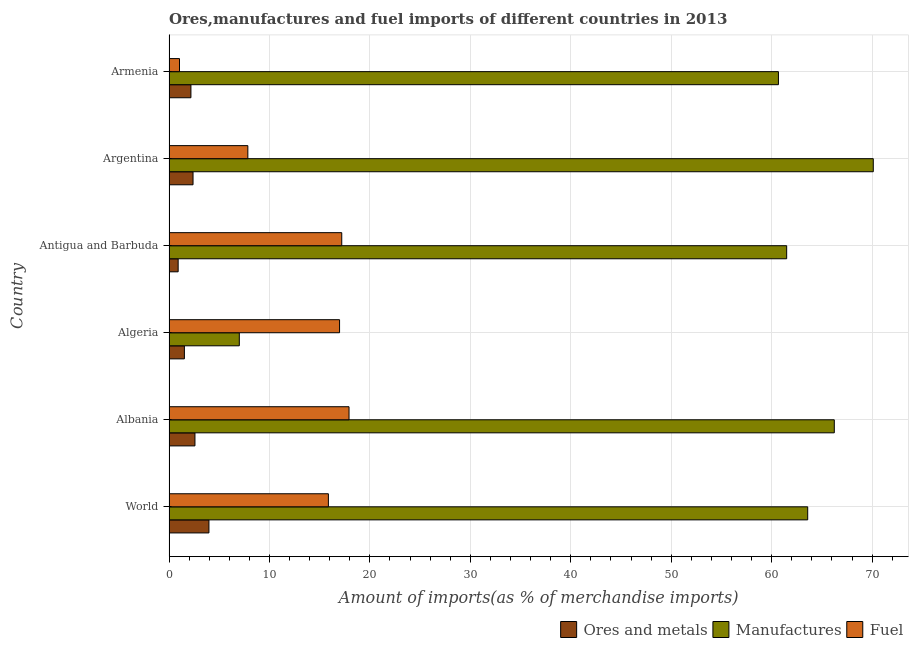How many groups of bars are there?
Offer a terse response. 6. Are the number of bars per tick equal to the number of legend labels?
Provide a succinct answer. Yes. What is the label of the 6th group of bars from the top?
Provide a short and direct response. World. What is the percentage of manufactures imports in World?
Provide a short and direct response. 63.59. Across all countries, what is the maximum percentage of manufactures imports?
Offer a terse response. 70.11. Across all countries, what is the minimum percentage of manufactures imports?
Make the answer very short. 7. In which country was the percentage of ores and metals imports maximum?
Provide a short and direct response. World. In which country was the percentage of fuel imports minimum?
Offer a terse response. Armenia. What is the total percentage of fuel imports in the graph?
Ensure brevity in your answer.  76.86. What is the difference between the percentage of manufactures imports in Albania and that in Antigua and Barbuda?
Your response must be concise. 4.74. What is the difference between the percentage of fuel imports in Argentina and the percentage of manufactures imports in Algeria?
Provide a short and direct response. 0.85. What is the average percentage of ores and metals imports per country?
Provide a succinct answer. 2.26. What is the difference between the percentage of fuel imports and percentage of ores and metals imports in Armenia?
Provide a short and direct response. -1.14. What is the ratio of the percentage of manufactures imports in Albania to that in Algeria?
Your response must be concise. 9.46. Is the difference between the percentage of manufactures imports in Armenia and World greater than the difference between the percentage of ores and metals imports in Armenia and World?
Provide a short and direct response. No. What is the difference between the highest and the second highest percentage of manufactures imports?
Your answer should be very brief. 3.88. What is the difference between the highest and the lowest percentage of manufactures imports?
Provide a succinct answer. 63.11. What does the 3rd bar from the top in Argentina represents?
Your response must be concise. Ores and metals. What does the 2nd bar from the bottom in World represents?
Provide a short and direct response. Manufactures. Is it the case that in every country, the sum of the percentage of ores and metals imports and percentage of manufactures imports is greater than the percentage of fuel imports?
Ensure brevity in your answer.  No. Are the values on the major ticks of X-axis written in scientific E-notation?
Offer a very short reply. No. Does the graph contain any zero values?
Provide a succinct answer. No. Where does the legend appear in the graph?
Your answer should be compact. Bottom right. How are the legend labels stacked?
Give a very brief answer. Horizontal. What is the title of the graph?
Make the answer very short. Ores,manufactures and fuel imports of different countries in 2013. Does "Industrial Nitrous Oxide" appear as one of the legend labels in the graph?
Make the answer very short. No. What is the label or title of the X-axis?
Provide a short and direct response. Amount of imports(as % of merchandise imports). What is the Amount of imports(as % of merchandise imports) in Ores and metals in World?
Your answer should be compact. 3.98. What is the Amount of imports(as % of merchandise imports) in Manufactures in World?
Your answer should be very brief. 63.59. What is the Amount of imports(as % of merchandise imports) in Fuel in World?
Your answer should be compact. 15.87. What is the Amount of imports(as % of merchandise imports) of Ores and metals in Albania?
Provide a succinct answer. 2.58. What is the Amount of imports(as % of merchandise imports) in Manufactures in Albania?
Provide a succinct answer. 66.23. What is the Amount of imports(as % of merchandise imports) of Fuel in Albania?
Your response must be concise. 17.92. What is the Amount of imports(as % of merchandise imports) of Ores and metals in Algeria?
Your answer should be very brief. 1.53. What is the Amount of imports(as % of merchandise imports) of Manufactures in Algeria?
Offer a terse response. 7. What is the Amount of imports(as % of merchandise imports) in Fuel in Algeria?
Offer a very short reply. 16.98. What is the Amount of imports(as % of merchandise imports) of Ores and metals in Antigua and Barbuda?
Provide a succinct answer. 0.91. What is the Amount of imports(as % of merchandise imports) of Manufactures in Antigua and Barbuda?
Make the answer very short. 61.49. What is the Amount of imports(as % of merchandise imports) of Fuel in Antigua and Barbuda?
Your answer should be compact. 17.2. What is the Amount of imports(as % of merchandise imports) of Ores and metals in Argentina?
Provide a short and direct response. 2.39. What is the Amount of imports(as % of merchandise imports) of Manufactures in Argentina?
Offer a very short reply. 70.11. What is the Amount of imports(as % of merchandise imports) of Fuel in Argentina?
Provide a short and direct response. 7.85. What is the Amount of imports(as % of merchandise imports) of Ores and metals in Armenia?
Offer a very short reply. 2.18. What is the Amount of imports(as % of merchandise imports) in Manufactures in Armenia?
Your answer should be very brief. 60.67. What is the Amount of imports(as % of merchandise imports) of Fuel in Armenia?
Your answer should be very brief. 1.05. Across all countries, what is the maximum Amount of imports(as % of merchandise imports) in Ores and metals?
Give a very brief answer. 3.98. Across all countries, what is the maximum Amount of imports(as % of merchandise imports) of Manufactures?
Ensure brevity in your answer.  70.11. Across all countries, what is the maximum Amount of imports(as % of merchandise imports) in Fuel?
Ensure brevity in your answer.  17.92. Across all countries, what is the minimum Amount of imports(as % of merchandise imports) of Ores and metals?
Provide a succinct answer. 0.91. Across all countries, what is the minimum Amount of imports(as % of merchandise imports) in Manufactures?
Give a very brief answer. 7. Across all countries, what is the minimum Amount of imports(as % of merchandise imports) of Fuel?
Make the answer very short. 1.05. What is the total Amount of imports(as % of merchandise imports) in Ores and metals in the graph?
Provide a short and direct response. 13.58. What is the total Amount of imports(as % of merchandise imports) of Manufactures in the graph?
Give a very brief answer. 329.09. What is the total Amount of imports(as % of merchandise imports) of Fuel in the graph?
Provide a succinct answer. 76.86. What is the difference between the Amount of imports(as % of merchandise imports) in Ores and metals in World and that in Albania?
Provide a succinct answer. 1.39. What is the difference between the Amount of imports(as % of merchandise imports) in Manufactures in World and that in Albania?
Your answer should be very brief. -2.65. What is the difference between the Amount of imports(as % of merchandise imports) of Fuel in World and that in Albania?
Offer a terse response. -2.05. What is the difference between the Amount of imports(as % of merchandise imports) of Ores and metals in World and that in Algeria?
Give a very brief answer. 2.44. What is the difference between the Amount of imports(as % of merchandise imports) of Manufactures in World and that in Algeria?
Give a very brief answer. 56.59. What is the difference between the Amount of imports(as % of merchandise imports) in Fuel in World and that in Algeria?
Your response must be concise. -1.11. What is the difference between the Amount of imports(as % of merchandise imports) of Ores and metals in World and that in Antigua and Barbuda?
Make the answer very short. 3.06. What is the difference between the Amount of imports(as % of merchandise imports) of Manufactures in World and that in Antigua and Barbuda?
Provide a succinct answer. 2.09. What is the difference between the Amount of imports(as % of merchandise imports) in Fuel in World and that in Antigua and Barbuda?
Offer a terse response. -1.33. What is the difference between the Amount of imports(as % of merchandise imports) in Ores and metals in World and that in Argentina?
Offer a very short reply. 1.58. What is the difference between the Amount of imports(as % of merchandise imports) of Manufactures in World and that in Argentina?
Your answer should be compact. -6.53. What is the difference between the Amount of imports(as % of merchandise imports) of Fuel in World and that in Argentina?
Make the answer very short. 8.02. What is the difference between the Amount of imports(as % of merchandise imports) of Ores and metals in World and that in Armenia?
Your response must be concise. 1.79. What is the difference between the Amount of imports(as % of merchandise imports) of Manufactures in World and that in Armenia?
Keep it short and to the point. 2.91. What is the difference between the Amount of imports(as % of merchandise imports) of Fuel in World and that in Armenia?
Make the answer very short. 14.82. What is the difference between the Amount of imports(as % of merchandise imports) of Ores and metals in Albania and that in Algeria?
Your answer should be compact. 1.05. What is the difference between the Amount of imports(as % of merchandise imports) of Manufactures in Albania and that in Algeria?
Provide a short and direct response. 59.23. What is the difference between the Amount of imports(as % of merchandise imports) in Fuel in Albania and that in Algeria?
Offer a very short reply. 0.94. What is the difference between the Amount of imports(as % of merchandise imports) in Ores and metals in Albania and that in Antigua and Barbuda?
Provide a succinct answer. 1.67. What is the difference between the Amount of imports(as % of merchandise imports) of Manufactures in Albania and that in Antigua and Barbuda?
Your answer should be compact. 4.74. What is the difference between the Amount of imports(as % of merchandise imports) in Fuel in Albania and that in Antigua and Barbuda?
Make the answer very short. 0.72. What is the difference between the Amount of imports(as % of merchandise imports) in Ores and metals in Albania and that in Argentina?
Offer a very short reply. 0.19. What is the difference between the Amount of imports(as % of merchandise imports) of Manufactures in Albania and that in Argentina?
Your answer should be compact. -3.88. What is the difference between the Amount of imports(as % of merchandise imports) of Fuel in Albania and that in Argentina?
Provide a short and direct response. 10.07. What is the difference between the Amount of imports(as % of merchandise imports) in Ores and metals in Albania and that in Armenia?
Make the answer very short. 0.4. What is the difference between the Amount of imports(as % of merchandise imports) in Manufactures in Albania and that in Armenia?
Your answer should be compact. 5.56. What is the difference between the Amount of imports(as % of merchandise imports) of Fuel in Albania and that in Armenia?
Provide a succinct answer. 16.88. What is the difference between the Amount of imports(as % of merchandise imports) of Ores and metals in Algeria and that in Antigua and Barbuda?
Your response must be concise. 0.62. What is the difference between the Amount of imports(as % of merchandise imports) in Manufactures in Algeria and that in Antigua and Barbuda?
Your answer should be very brief. -54.49. What is the difference between the Amount of imports(as % of merchandise imports) of Fuel in Algeria and that in Antigua and Barbuda?
Provide a short and direct response. -0.22. What is the difference between the Amount of imports(as % of merchandise imports) in Ores and metals in Algeria and that in Argentina?
Give a very brief answer. -0.86. What is the difference between the Amount of imports(as % of merchandise imports) of Manufactures in Algeria and that in Argentina?
Your answer should be very brief. -63.11. What is the difference between the Amount of imports(as % of merchandise imports) of Fuel in Algeria and that in Argentina?
Keep it short and to the point. 9.13. What is the difference between the Amount of imports(as % of merchandise imports) of Ores and metals in Algeria and that in Armenia?
Your answer should be compact. -0.65. What is the difference between the Amount of imports(as % of merchandise imports) of Manufactures in Algeria and that in Armenia?
Make the answer very short. -53.67. What is the difference between the Amount of imports(as % of merchandise imports) in Fuel in Algeria and that in Armenia?
Keep it short and to the point. 15.93. What is the difference between the Amount of imports(as % of merchandise imports) in Ores and metals in Antigua and Barbuda and that in Argentina?
Your answer should be very brief. -1.48. What is the difference between the Amount of imports(as % of merchandise imports) in Manufactures in Antigua and Barbuda and that in Argentina?
Keep it short and to the point. -8.62. What is the difference between the Amount of imports(as % of merchandise imports) in Fuel in Antigua and Barbuda and that in Argentina?
Offer a terse response. 9.35. What is the difference between the Amount of imports(as % of merchandise imports) in Ores and metals in Antigua and Barbuda and that in Armenia?
Make the answer very short. -1.27. What is the difference between the Amount of imports(as % of merchandise imports) in Manufactures in Antigua and Barbuda and that in Armenia?
Keep it short and to the point. 0.82. What is the difference between the Amount of imports(as % of merchandise imports) in Fuel in Antigua and Barbuda and that in Armenia?
Make the answer very short. 16.15. What is the difference between the Amount of imports(as % of merchandise imports) in Ores and metals in Argentina and that in Armenia?
Offer a terse response. 0.21. What is the difference between the Amount of imports(as % of merchandise imports) in Manufactures in Argentina and that in Armenia?
Keep it short and to the point. 9.44. What is the difference between the Amount of imports(as % of merchandise imports) of Fuel in Argentina and that in Armenia?
Keep it short and to the point. 6.8. What is the difference between the Amount of imports(as % of merchandise imports) of Ores and metals in World and the Amount of imports(as % of merchandise imports) of Manufactures in Albania?
Your answer should be compact. -62.26. What is the difference between the Amount of imports(as % of merchandise imports) in Ores and metals in World and the Amount of imports(as % of merchandise imports) in Fuel in Albania?
Your response must be concise. -13.95. What is the difference between the Amount of imports(as % of merchandise imports) of Manufactures in World and the Amount of imports(as % of merchandise imports) of Fuel in Albania?
Your answer should be very brief. 45.66. What is the difference between the Amount of imports(as % of merchandise imports) of Ores and metals in World and the Amount of imports(as % of merchandise imports) of Manufactures in Algeria?
Keep it short and to the point. -3.02. What is the difference between the Amount of imports(as % of merchandise imports) in Ores and metals in World and the Amount of imports(as % of merchandise imports) in Fuel in Algeria?
Your response must be concise. -13. What is the difference between the Amount of imports(as % of merchandise imports) in Manufactures in World and the Amount of imports(as % of merchandise imports) in Fuel in Algeria?
Provide a short and direct response. 46.61. What is the difference between the Amount of imports(as % of merchandise imports) of Ores and metals in World and the Amount of imports(as % of merchandise imports) of Manufactures in Antigua and Barbuda?
Give a very brief answer. -57.52. What is the difference between the Amount of imports(as % of merchandise imports) in Ores and metals in World and the Amount of imports(as % of merchandise imports) in Fuel in Antigua and Barbuda?
Give a very brief answer. -13.22. What is the difference between the Amount of imports(as % of merchandise imports) of Manufactures in World and the Amount of imports(as % of merchandise imports) of Fuel in Antigua and Barbuda?
Offer a terse response. 46.39. What is the difference between the Amount of imports(as % of merchandise imports) in Ores and metals in World and the Amount of imports(as % of merchandise imports) in Manufactures in Argentina?
Offer a terse response. -66.14. What is the difference between the Amount of imports(as % of merchandise imports) in Ores and metals in World and the Amount of imports(as % of merchandise imports) in Fuel in Argentina?
Make the answer very short. -3.87. What is the difference between the Amount of imports(as % of merchandise imports) in Manufactures in World and the Amount of imports(as % of merchandise imports) in Fuel in Argentina?
Offer a terse response. 55.74. What is the difference between the Amount of imports(as % of merchandise imports) in Ores and metals in World and the Amount of imports(as % of merchandise imports) in Manufactures in Armenia?
Ensure brevity in your answer.  -56.7. What is the difference between the Amount of imports(as % of merchandise imports) in Ores and metals in World and the Amount of imports(as % of merchandise imports) in Fuel in Armenia?
Your response must be concise. 2.93. What is the difference between the Amount of imports(as % of merchandise imports) in Manufactures in World and the Amount of imports(as % of merchandise imports) in Fuel in Armenia?
Provide a short and direct response. 62.54. What is the difference between the Amount of imports(as % of merchandise imports) in Ores and metals in Albania and the Amount of imports(as % of merchandise imports) in Manufactures in Algeria?
Offer a very short reply. -4.42. What is the difference between the Amount of imports(as % of merchandise imports) of Ores and metals in Albania and the Amount of imports(as % of merchandise imports) of Fuel in Algeria?
Give a very brief answer. -14.4. What is the difference between the Amount of imports(as % of merchandise imports) of Manufactures in Albania and the Amount of imports(as % of merchandise imports) of Fuel in Algeria?
Your answer should be very brief. 49.25. What is the difference between the Amount of imports(as % of merchandise imports) in Ores and metals in Albania and the Amount of imports(as % of merchandise imports) in Manufactures in Antigua and Barbuda?
Offer a very short reply. -58.91. What is the difference between the Amount of imports(as % of merchandise imports) in Ores and metals in Albania and the Amount of imports(as % of merchandise imports) in Fuel in Antigua and Barbuda?
Give a very brief answer. -14.61. What is the difference between the Amount of imports(as % of merchandise imports) of Manufactures in Albania and the Amount of imports(as % of merchandise imports) of Fuel in Antigua and Barbuda?
Your answer should be very brief. 49.03. What is the difference between the Amount of imports(as % of merchandise imports) of Ores and metals in Albania and the Amount of imports(as % of merchandise imports) of Manufactures in Argentina?
Your answer should be compact. -67.53. What is the difference between the Amount of imports(as % of merchandise imports) in Ores and metals in Albania and the Amount of imports(as % of merchandise imports) in Fuel in Argentina?
Keep it short and to the point. -5.27. What is the difference between the Amount of imports(as % of merchandise imports) of Manufactures in Albania and the Amount of imports(as % of merchandise imports) of Fuel in Argentina?
Keep it short and to the point. 58.38. What is the difference between the Amount of imports(as % of merchandise imports) of Ores and metals in Albania and the Amount of imports(as % of merchandise imports) of Manufactures in Armenia?
Make the answer very short. -58.09. What is the difference between the Amount of imports(as % of merchandise imports) of Ores and metals in Albania and the Amount of imports(as % of merchandise imports) of Fuel in Armenia?
Provide a short and direct response. 1.54. What is the difference between the Amount of imports(as % of merchandise imports) of Manufactures in Albania and the Amount of imports(as % of merchandise imports) of Fuel in Armenia?
Give a very brief answer. 65.19. What is the difference between the Amount of imports(as % of merchandise imports) in Ores and metals in Algeria and the Amount of imports(as % of merchandise imports) in Manufactures in Antigua and Barbuda?
Ensure brevity in your answer.  -59.96. What is the difference between the Amount of imports(as % of merchandise imports) of Ores and metals in Algeria and the Amount of imports(as % of merchandise imports) of Fuel in Antigua and Barbuda?
Ensure brevity in your answer.  -15.67. What is the difference between the Amount of imports(as % of merchandise imports) of Manufactures in Algeria and the Amount of imports(as % of merchandise imports) of Fuel in Antigua and Barbuda?
Make the answer very short. -10.2. What is the difference between the Amount of imports(as % of merchandise imports) of Ores and metals in Algeria and the Amount of imports(as % of merchandise imports) of Manufactures in Argentina?
Give a very brief answer. -68.58. What is the difference between the Amount of imports(as % of merchandise imports) in Ores and metals in Algeria and the Amount of imports(as % of merchandise imports) in Fuel in Argentina?
Provide a short and direct response. -6.32. What is the difference between the Amount of imports(as % of merchandise imports) in Manufactures in Algeria and the Amount of imports(as % of merchandise imports) in Fuel in Argentina?
Offer a terse response. -0.85. What is the difference between the Amount of imports(as % of merchandise imports) in Ores and metals in Algeria and the Amount of imports(as % of merchandise imports) in Manufactures in Armenia?
Offer a very short reply. -59.14. What is the difference between the Amount of imports(as % of merchandise imports) of Ores and metals in Algeria and the Amount of imports(as % of merchandise imports) of Fuel in Armenia?
Your answer should be compact. 0.49. What is the difference between the Amount of imports(as % of merchandise imports) of Manufactures in Algeria and the Amount of imports(as % of merchandise imports) of Fuel in Armenia?
Keep it short and to the point. 5.95. What is the difference between the Amount of imports(as % of merchandise imports) in Ores and metals in Antigua and Barbuda and the Amount of imports(as % of merchandise imports) in Manufactures in Argentina?
Offer a very short reply. -69.2. What is the difference between the Amount of imports(as % of merchandise imports) of Ores and metals in Antigua and Barbuda and the Amount of imports(as % of merchandise imports) of Fuel in Argentina?
Your answer should be compact. -6.94. What is the difference between the Amount of imports(as % of merchandise imports) in Manufactures in Antigua and Barbuda and the Amount of imports(as % of merchandise imports) in Fuel in Argentina?
Your answer should be very brief. 53.64. What is the difference between the Amount of imports(as % of merchandise imports) of Ores and metals in Antigua and Barbuda and the Amount of imports(as % of merchandise imports) of Manufactures in Armenia?
Offer a terse response. -59.76. What is the difference between the Amount of imports(as % of merchandise imports) in Ores and metals in Antigua and Barbuda and the Amount of imports(as % of merchandise imports) in Fuel in Armenia?
Provide a succinct answer. -0.13. What is the difference between the Amount of imports(as % of merchandise imports) of Manufactures in Antigua and Barbuda and the Amount of imports(as % of merchandise imports) of Fuel in Armenia?
Ensure brevity in your answer.  60.45. What is the difference between the Amount of imports(as % of merchandise imports) in Ores and metals in Argentina and the Amount of imports(as % of merchandise imports) in Manufactures in Armenia?
Provide a succinct answer. -58.28. What is the difference between the Amount of imports(as % of merchandise imports) of Ores and metals in Argentina and the Amount of imports(as % of merchandise imports) of Fuel in Armenia?
Make the answer very short. 1.35. What is the difference between the Amount of imports(as % of merchandise imports) in Manufactures in Argentina and the Amount of imports(as % of merchandise imports) in Fuel in Armenia?
Keep it short and to the point. 69.07. What is the average Amount of imports(as % of merchandise imports) in Ores and metals per country?
Offer a terse response. 2.26. What is the average Amount of imports(as % of merchandise imports) in Manufactures per country?
Offer a terse response. 54.85. What is the average Amount of imports(as % of merchandise imports) in Fuel per country?
Ensure brevity in your answer.  12.81. What is the difference between the Amount of imports(as % of merchandise imports) of Ores and metals and Amount of imports(as % of merchandise imports) of Manufactures in World?
Your answer should be compact. -59.61. What is the difference between the Amount of imports(as % of merchandise imports) of Ores and metals and Amount of imports(as % of merchandise imports) of Fuel in World?
Ensure brevity in your answer.  -11.89. What is the difference between the Amount of imports(as % of merchandise imports) in Manufactures and Amount of imports(as % of merchandise imports) in Fuel in World?
Offer a very short reply. 47.72. What is the difference between the Amount of imports(as % of merchandise imports) in Ores and metals and Amount of imports(as % of merchandise imports) in Manufactures in Albania?
Offer a terse response. -63.65. What is the difference between the Amount of imports(as % of merchandise imports) in Ores and metals and Amount of imports(as % of merchandise imports) in Fuel in Albania?
Your response must be concise. -15.34. What is the difference between the Amount of imports(as % of merchandise imports) in Manufactures and Amount of imports(as % of merchandise imports) in Fuel in Albania?
Give a very brief answer. 48.31. What is the difference between the Amount of imports(as % of merchandise imports) of Ores and metals and Amount of imports(as % of merchandise imports) of Manufactures in Algeria?
Ensure brevity in your answer.  -5.47. What is the difference between the Amount of imports(as % of merchandise imports) of Ores and metals and Amount of imports(as % of merchandise imports) of Fuel in Algeria?
Your answer should be very brief. -15.45. What is the difference between the Amount of imports(as % of merchandise imports) of Manufactures and Amount of imports(as % of merchandise imports) of Fuel in Algeria?
Ensure brevity in your answer.  -9.98. What is the difference between the Amount of imports(as % of merchandise imports) of Ores and metals and Amount of imports(as % of merchandise imports) of Manufactures in Antigua and Barbuda?
Your answer should be compact. -60.58. What is the difference between the Amount of imports(as % of merchandise imports) of Ores and metals and Amount of imports(as % of merchandise imports) of Fuel in Antigua and Barbuda?
Provide a succinct answer. -16.29. What is the difference between the Amount of imports(as % of merchandise imports) of Manufactures and Amount of imports(as % of merchandise imports) of Fuel in Antigua and Barbuda?
Give a very brief answer. 44.29. What is the difference between the Amount of imports(as % of merchandise imports) in Ores and metals and Amount of imports(as % of merchandise imports) in Manufactures in Argentina?
Make the answer very short. -67.72. What is the difference between the Amount of imports(as % of merchandise imports) of Ores and metals and Amount of imports(as % of merchandise imports) of Fuel in Argentina?
Your answer should be very brief. -5.46. What is the difference between the Amount of imports(as % of merchandise imports) in Manufactures and Amount of imports(as % of merchandise imports) in Fuel in Argentina?
Make the answer very short. 62.26. What is the difference between the Amount of imports(as % of merchandise imports) in Ores and metals and Amount of imports(as % of merchandise imports) in Manufactures in Armenia?
Ensure brevity in your answer.  -58.49. What is the difference between the Amount of imports(as % of merchandise imports) of Ores and metals and Amount of imports(as % of merchandise imports) of Fuel in Armenia?
Give a very brief answer. 1.14. What is the difference between the Amount of imports(as % of merchandise imports) in Manufactures and Amount of imports(as % of merchandise imports) in Fuel in Armenia?
Provide a succinct answer. 59.63. What is the ratio of the Amount of imports(as % of merchandise imports) in Ores and metals in World to that in Albania?
Make the answer very short. 1.54. What is the ratio of the Amount of imports(as % of merchandise imports) of Fuel in World to that in Albania?
Your answer should be compact. 0.89. What is the ratio of the Amount of imports(as % of merchandise imports) of Ores and metals in World to that in Algeria?
Offer a very short reply. 2.6. What is the ratio of the Amount of imports(as % of merchandise imports) in Manufactures in World to that in Algeria?
Keep it short and to the point. 9.08. What is the ratio of the Amount of imports(as % of merchandise imports) in Fuel in World to that in Algeria?
Give a very brief answer. 0.93. What is the ratio of the Amount of imports(as % of merchandise imports) in Ores and metals in World to that in Antigua and Barbuda?
Give a very brief answer. 4.36. What is the ratio of the Amount of imports(as % of merchandise imports) of Manufactures in World to that in Antigua and Barbuda?
Your response must be concise. 1.03. What is the ratio of the Amount of imports(as % of merchandise imports) of Fuel in World to that in Antigua and Barbuda?
Make the answer very short. 0.92. What is the ratio of the Amount of imports(as % of merchandise imports) of Ores and metals in World to that in Argentina?
Offer a very short reply. 1.66. What is the ratio of the Amount of imports(as % of merchandise imports) of Manufactures in World to that in Argentina?
Ensure brevity in your answer.  0.91. What is the ratio of the Amount of imports(as % of merchandise imports) of Fuel in World to that in Argentina?
Keep it short and to the point. 2.02. What is the ratio of the Amount of imports(as % of merchandise imports) of Ores and metals in World to that in Armenia?
Keep it short and to the point. 1.82. What is the ratio of the Amount of imports(as % of merchandise imports) in Manufactures in World to that in Armenia?
Your answer should be compact. 1.05. What is the ratio of the Amount of imports(as % of merchandise imports) in Fuel in World to that in Armenia?
Make the answer very short. 15.18. What is the ratio of the Amount of imports(as % of merchandise imports) in Ores and metals in Albania to that in Algeria?
Provide a short and direct response. 1.69. What is the ratio of the Amount of imports(as % of merchandise imports) in Manufactures in Albania to that in Algeria?
Provide a succinct answer. 9.46. What is the ratio of the Amount of imports(as % of merchandise imports) of Fuel in Albania to that in Algeria?
Your answer should be very brief. 1.06. What is the ratio of the Amount of imports(as % of merchandise imports) of Ores and metals in Albania to that in Antigua and Barbuda?
Give a very brief answer. 2.84. What is the ratio of the Amount of imports(as % of merchandise imports) in Manufactures in Albania to that in Antigua and Barbuda?
Offer a very short reply. 1.08. What is the ratio of the Amount of imports(as % of merchandise imports) in Fuel in Albania to that in Antigua and Barbuda?
Keep it short and to the point. 1.04. What is the ratio of the Amount of imports(as % of merchandise imports) in Ores and metals in Albania to that in Argentina?
Your response must be concise. 1.08. What is the ratio of the Amount of imports(as % of merchandise imports) of Manufactures in Albania to that in Argentina?
Ensure brevity in your answer.  0.94. What is the ratio of the Amount of imports(as % of merchandise imports) of Fuel in Albania to that in Argentina?
Make the answer very short. 2.28. What is the ratio of the Amount of imports(as % of merchandise imports) in Ores and metals in Albania to that in Armenia?
Keep it short and to the point. 1.18. What is the ratio of the Amount of imports(as % of merchandise imports) of Manufactures in Albania to that in Armenia?
Your response must be concise. 1.09. What is the ratio of the Amount of imports(as % of merchandise imports) in Fuel in Albania to that in Armenia?
Your answer should be very brief. 17.15. What is the ratio of the Amount of imports(as % of merchandise imports) of Ores and metals in Algeria to that in Antigua and Barbuda?
Your answer should be compact. 1.68. What is the ratio of the Amount of imports(as % of merchandise imports) in Manufactures in Algeria to that in Antigua and Barbuda?
Make the answer very short. 0.11. What is the ratio of the Amount of imports(as % of merchandise imports) of Fuel in Algeria to that in Antigua and Barbuda?
Keep it short and to the point. 0.99. What is the ratio of the Amount of imports(as % of merchandise imports) of Ores and metals in Algeria to that in Argentina?
Keep it short and to the point. 0.64. What is the ratio of the Amount of imports(as % of merchandise imports) in Manufactures in Algeria to that in Argentina?
Keep it short and to the point. 0.1. What is the ratio of the Amount of imports(as % of merchandise imports) in Fuel in Algeria to that in Argentina?
Give a very brief answer. 2.16. What is the ratio of the Amount of imports(as % of merchandise imports) of Ores and metals in Algeria to that in Armenia?
Offer a very short reply. 0.7. What is the ratio of the Amount of imports(as % of merchandise imports) of Manufactures in Algeria to that in Armenia?
Provide a succinct answer. 0.12. What is the ratio of the Amount of imports(as % of merchandise imports) in Fuel in Algeria to that in Armenia?
Offer a terse response. 16.24. What is the ratio of the Amount of imports(as % of merchandise imports) in Ores and metals in Antigua and Barbuda to that in Argentina?
Keep it short and to the point. 0.38. What is the ratio of the Amount of imports(as % of merchandise imports) in Manufactures in Antigua and Barbuda to that in Argentina?
Your response must be concise. 0.88. What is the ratio of the Amount of imports(as % of merchandise imports) of Fuel in Antigua and Barbuda to that in Argentina?
Ensure brevity in your answer.  2.19. What is the ratio of the Amount of imports(as % of merchandise imports) of Ores and metals in Antigua and Barbuda to that in Armenia?
Provide a short and direct response. 0.42. What is the ratio of the Amount of imports(as % of merchandise imports) of Manufactures in Antigua and Barbuda to that in Armenia?
Your response must be concise. 1.01. What is the ratio of the Amount of imports(as % of merchandise imports) of Fuel in Antigua and Barbuda to that in Armenia?
Offer a terse response. 16.45. What is the ratio of the Amount of imports(as % of merchandise imports) of Ores and metals in Argentina to that in Armenia?
Give a very brief answer. 1.1. What is the ratio of the Amount of imports(as % of merchandise imports) of Manufactures in Argentina to that in Armenia?
Provide a short and direct response. 1.16. What is the ratio of the Amount of imports(as % of merchandise imports) in Fuel in Argentina to that in Armenia?
Keep it short and to the point. 7.51. What is the difference between the highest and the second highest Amount of imports(as % of merchandise imports) in Ores and metals?
Give a very brief answer. 1.39. What is the difference between the highest and the second highest Amount of imports(as % of merchandise imports) of Manufactures?
Offer a very short reply. 3.88. What is the difference between the highest and the second highest Amount of imports(as % of merchandise imports) in Fuel?
Give a very brief answer. 0.72. What is the difference between the highest and the lowest Amount of imports(as % of merchandise imports) in Ores and metals?
Offer a very short reply. 3.06. What is the difference between the highest and the lowest Amount of imports(as % of merchandise imports) of Manufactures?
Offer a very short reply. 63.11. What is the difference between the highest and the lowest Amount of imports(as % of merchandise imports) of Fuel?
Make the answer very short. 16.88. 